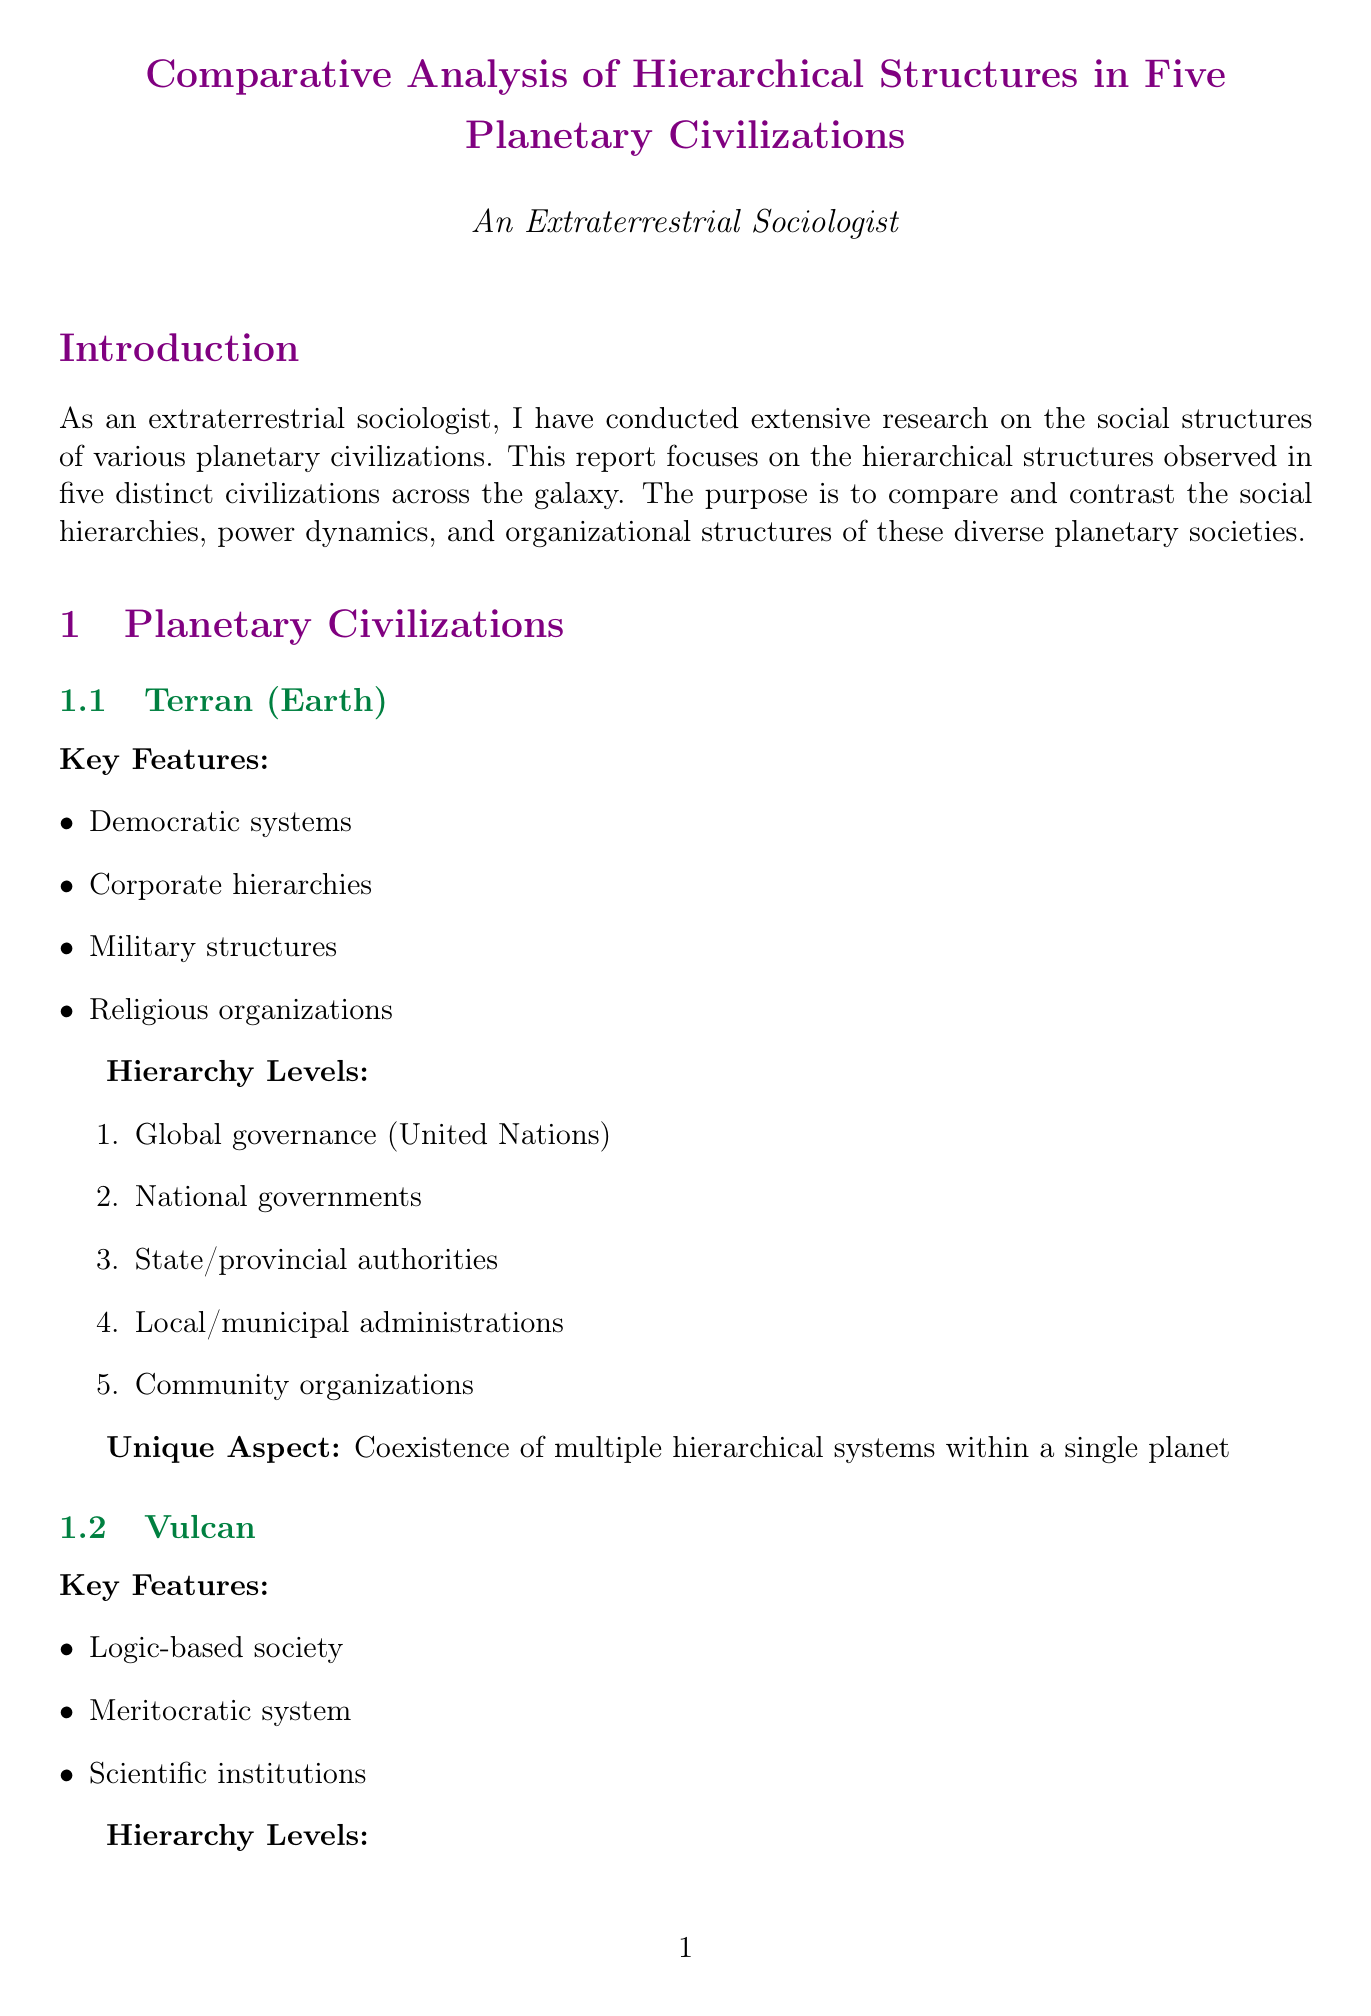What are the key features of the Terrestrial civilization? The key features of the Terrestrial civilization are mentioned in the section titled "Terran (Earth)." These features include democratic systems, corporate hierarchies, military structures, and religious organizations.
Answer: Democratic systems, corporate hierarchies, military structures, religious organizations What is the unique aspect of the Vulcan hierarchy? The unique aspect of the Vulcan hierarchy is highlighted in the section about Vulcan. It emphasizes logic and intellectual achievement in determining social status.
Answer: Emphasis on logic and intellectual achievement Which civilization has a warrior-based culture? To identify which civilization has a warrior-based culture, refer to the section titled "Klingon Empire." It describes a warrior-based culture as a key feature.
Answer: Klingon Empire How many levels are in the Ferengi hierarchy? The Ferengi hierarchy levels can be counted in the section dedicated to the Ferengi Alliance, which lists five distinct levels.
Answer: Five What factor influences social mobility in the Andorian Confederacy? The influencing factor on social mobility for the Andorian Confederacy is mentioned in the section on Social Mobility. It states that mobility is influenced by gender and clan affiliations.
Answer: Gender and clan affiliations Which civilization shows the most diverse power distribution? The comparative analysis section discusses power distribution. It specifies that Terran society shows the most diverse power distribution among the five civilizations analyzed.
Answer: Terran What is depicted in the "Social Mobility Heat Maps"? This question asks about the purpose of the visual diagram titled "Social Mobility Heat Maps," which is included in the Visual Diagrams section. It describes color-coded diagrams showing the relative ease of moving between social classes.
Answer: Relative ease of moving between social classes What summarizes the conclusions of the report? The conclusion section provides a summary of findings from the comparative analysis, capturing the diverse ways intelligent species organize their societies across the galaxy.
Answer: Diverse ways intelligent species organize their societies How is the decision-making process characterized for Vulcan society? The decision-making process for Vulcan society is described in the section on Decision Making Processes, highlighting that it is based on logical consensus.
Answer: Logical consensus 